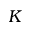<formula> <loc_0><loc_0><loc_500><loc_500>K</formula> 